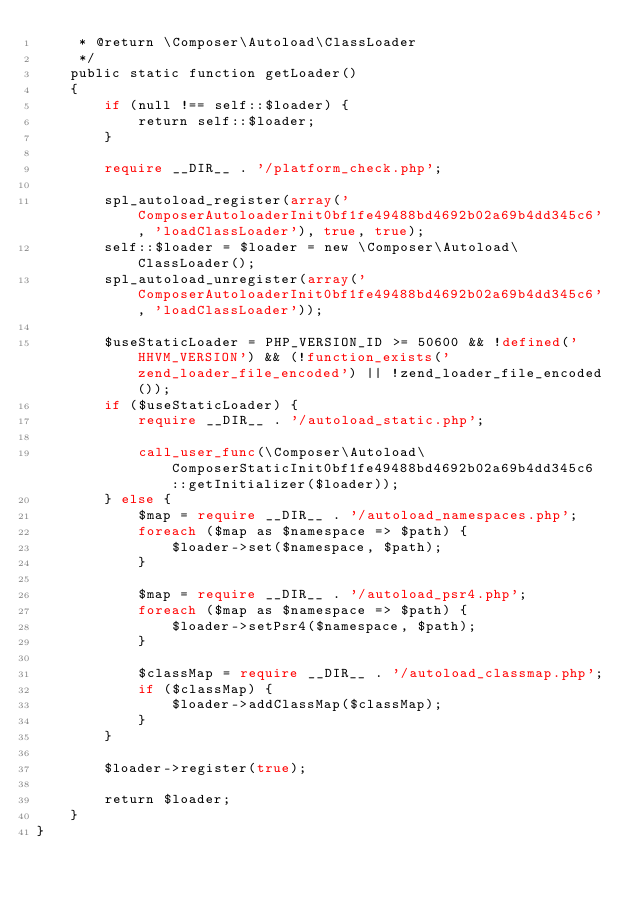Convert code to text. <code><loc_0><loc_0><loc_500><loc_500><_PHP_>     * @return \Composer\Autoload\ClassLoader
     */
    public static function getLoader()
    {
        if (null !== self::$loader) {
            return self::$loader;
        }

        require __DIR__ . '/platform_check.php';

        spl_autoload_register(array('ComposerAutoloaderInit0bf1fe49488bd4692b02a69b4dd345c6', 'loadClassLoader'), true, true);
        self::$loader = $loader = new \Composer\Autoload\ClassLoader();
        spl_autoload_unregister(array('ComposerAutoloaderInit0bf1fe49488bd4692b02a69b4dd345c6', 'loadClassLoader'));

        $useStaticLoader = PHP_VERSION_ID >= 50600 && !defined('HHVM_VERSION') && (!function_exists('zend_loader_file_encoded') || !zend_loader_file_encoded());
        if ($useStaticLoader) {
            require __DIR__ . '/autoload_static.php';

            call_user_func(\Composer\Autoload\ComposerStaticInit0bf1fe49488bd4692b02a69b4dd345c6::getInitializer($loader));
        } else {
            $map = require __DIR__ . '/autoload_namespaces.php';
            foreach ($map as $namespace => $path) {
                $loader->set($namespace, $path);
            }

            $map = require __DIR__ . '/autoload_psr4.php';
            foreach ($map as $namespace => $path) {
                $loader->setPsr4($namespace, $path);
            }

            $classMap = require __DIR__ . '/autoload_classmap.php';
            if ($classMap) {
                $loader->addClassMap($classMap);
            }
        }

        $loader->register(true);

        return $loader;
    }
}
</code> 